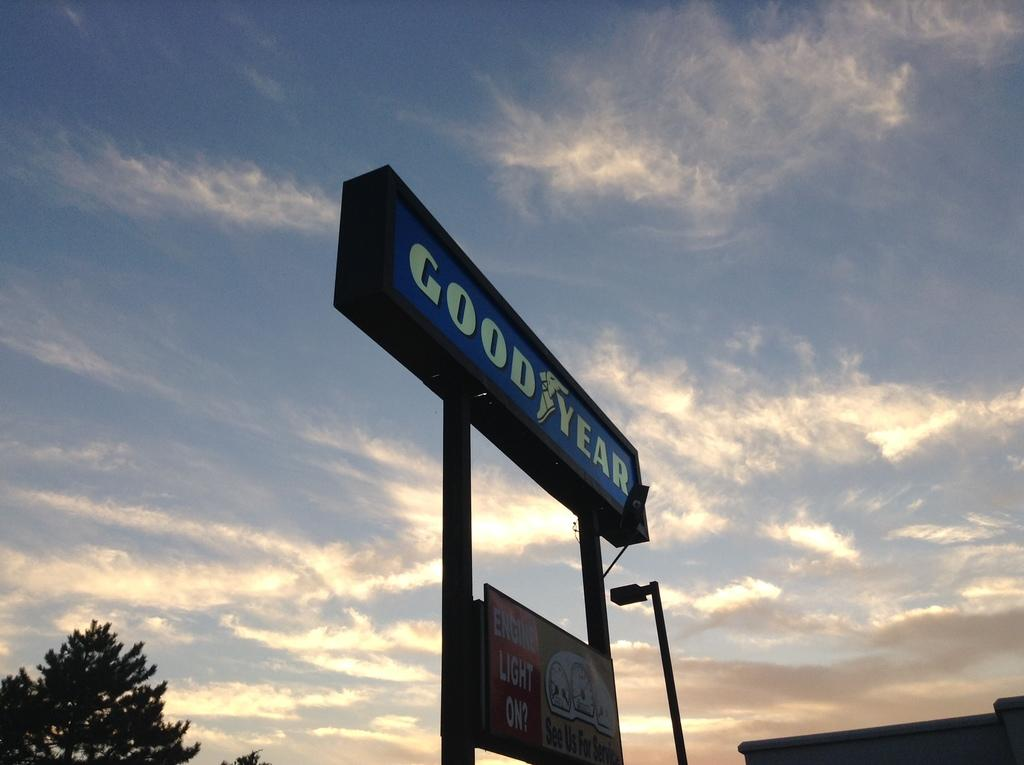<image>
Describe the image concisely. Good Year Banner on a black pole below a Engine light on Banner. 